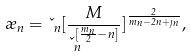<formula> <loc_0><loc_0><loc_500><loc_500>\rho _ { n } = \kappa _ { n } [ \frac { M } { \kappa _ { n } ^ { [ \frac { m _ { n } } { 2 } - n ] } } ] ^ { \frac { 2 } { m _ { n } - 2 n + \eta _ { n } } } ,</formula> 